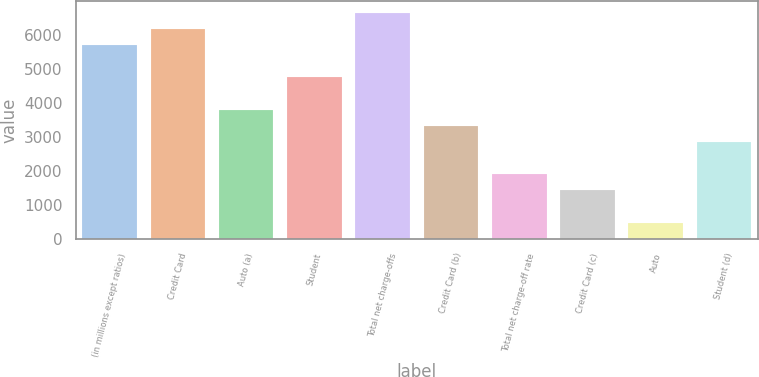Convert chart to OTSL. <chart><loc_0><loc_0><loc_500><loc_500><bar_chart><fcel>(in millions except ratios)<fcel>Credit Card<fcel>Auto (a)<fcel>Student<fcel>Total net charge-offs<fcel>Credit Card (b)<fcel>Total net charge-off rate<fcel>Credit Card (c)<fcel>Auto<fcel>Student (d)<nl><fcel>5697.44<fcel>6172.16<fcel>3798.56<fcel>4748<fcel>6646.88<fcel>3323.84<fcel>1899.68<fcel>1424.96<fcel>475.52<fcel>2849.12<nl></chart> 